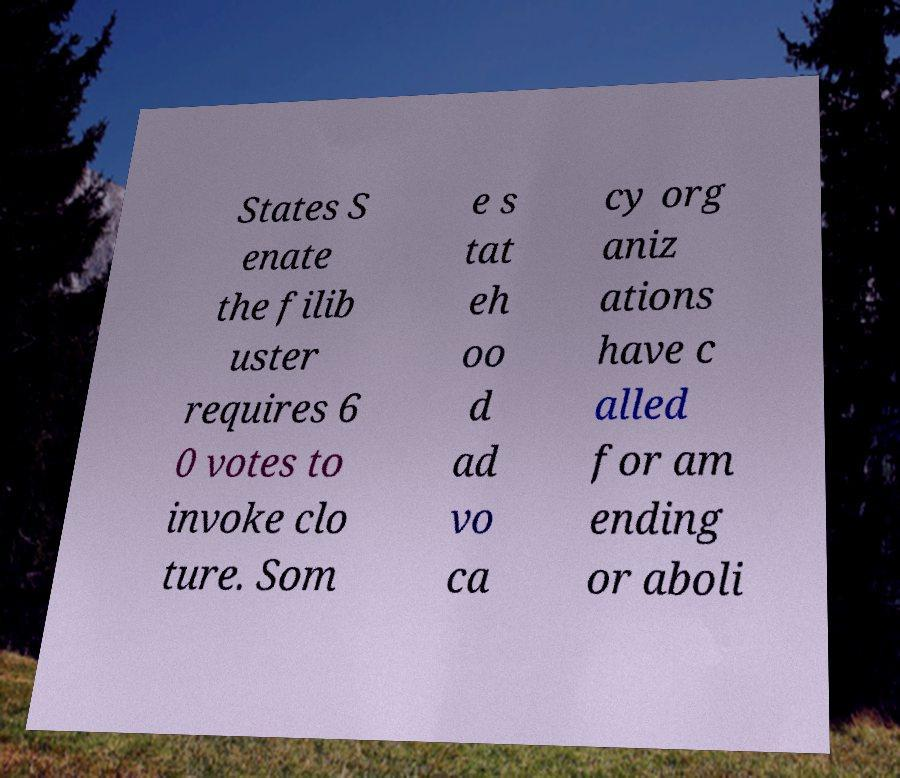What messages or text are displayed in this image? I need them in a readable, typed format. States S enate the filib uster requires 6 0 votes to invoke clo ture. Som e s tat eh oo d ad vo ca cy org aniz ations have c alled for am ending or aboli 